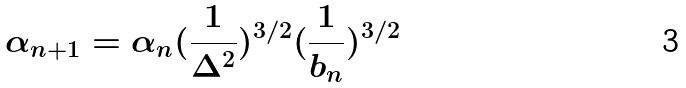Convert formula to latex. <formula><loc_0><loc_0><loc_500><loc_500>\alpha _ { n + 1 } = \alpha _ { n } ( \frac { 1 } { \Delta ^ { 2 } } ) ^ { 3 / 2 } ( \frac { 1 } { b _ { n } } ) ^ { 3 / 2 }</formula> 